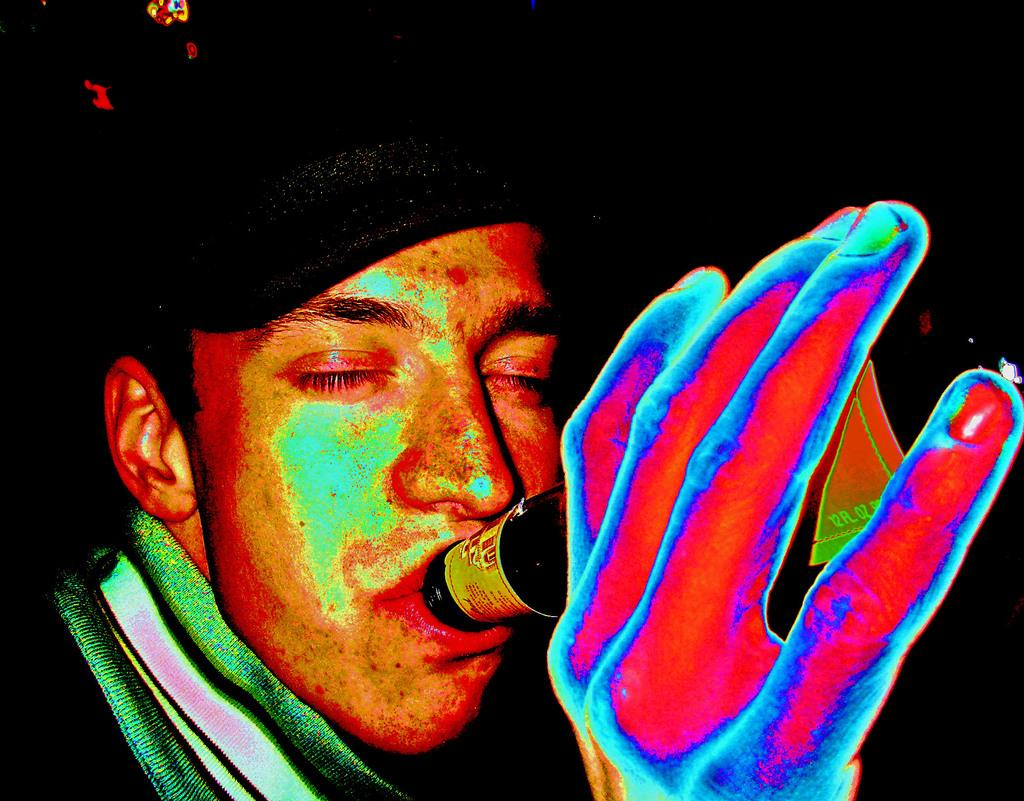Who is present in the image? There is a man in the image. What is the man doing in the image? The man is drinking in the image. What object is the man holding in his hand? The man is holding a bottle in his hand. What type of headwear is the man wearing? The man is wearing a cap on his head. How would you describe the lighting in the image? The background of the image is dark. Can you see any cactus plants in the image? There is no cactus plant present in the image. What part of the man's body is visible in the image? The image only shows the man's head and upper body, so it is not possible to see his entire body. 